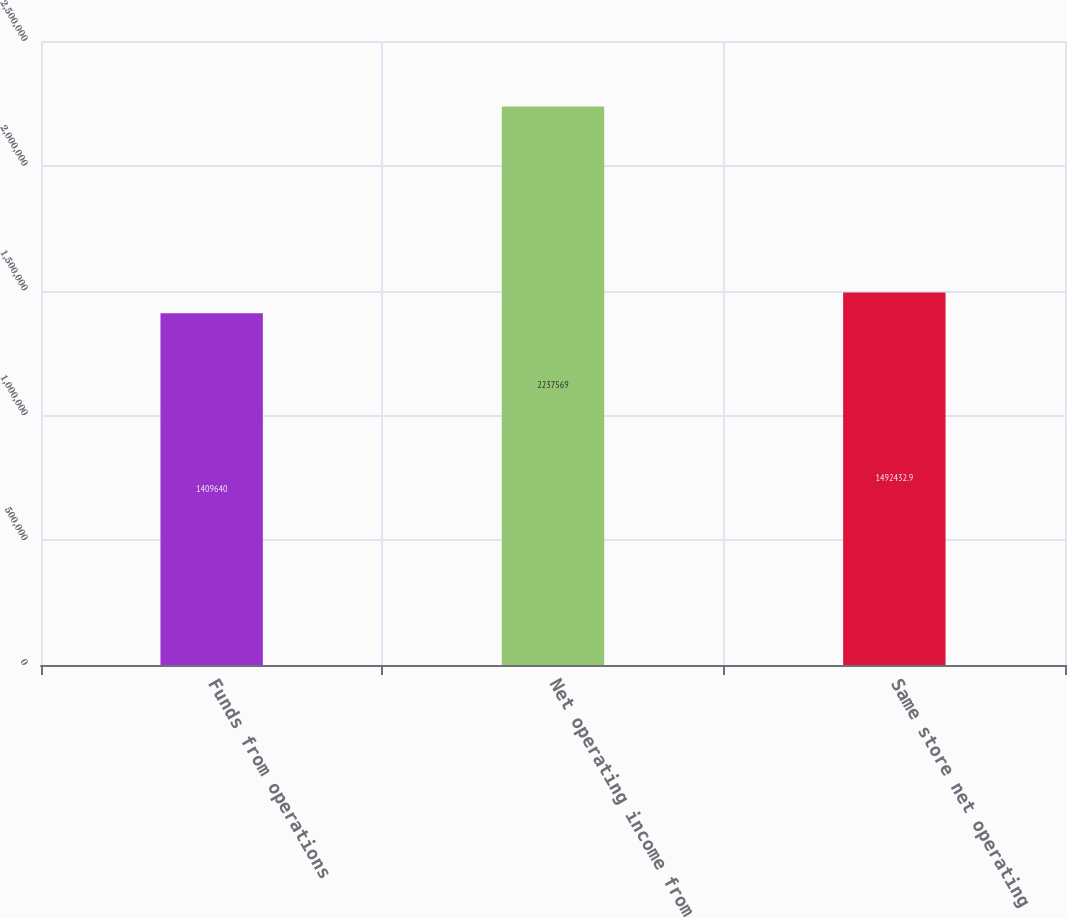Convert chart to OTSL. <chart><loc_0><loc_0><loc_500><loc_500><bar_chart><fcel>Funds from operations<fcel>Net operating income from<fcel>Same store net operating<nl><fcel>1.40964e+06<fcel>2.23757e+06<fcel>1.49243e+06<nl></chart> 